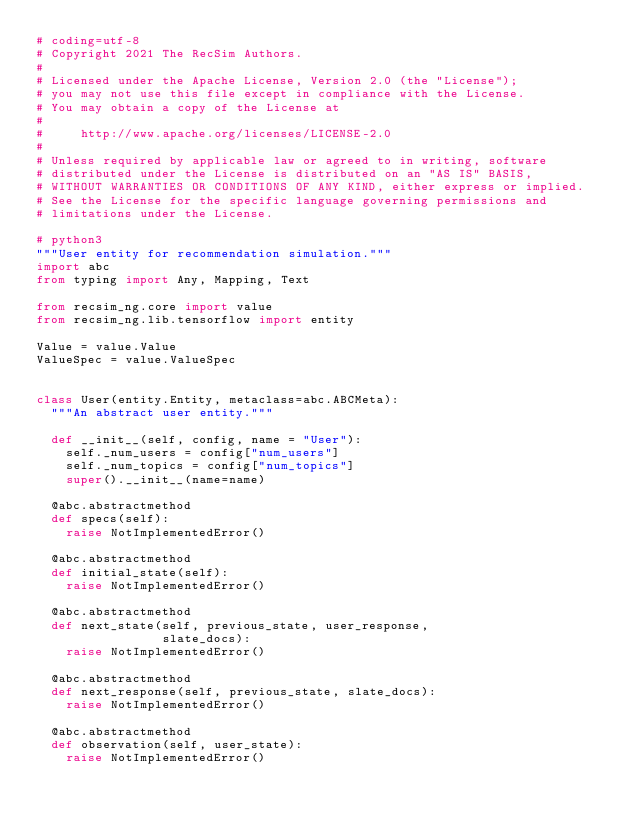Convert code to text. <code><loc_0><loc_0><loc_500><loc_500><_Python_># coding=utf-8
# Copyright 2021 The RecSim Authors.
#
# Licensed under the Apache License, Version 2.0 (the "License");
# you may not use this file except in compliance with the License.
# You may obtain a copy of the License at
#
#     http://www.apache.org/licenses/LICENSE-2.0
#
# Unless required by applicable law or agreed to in writing, software
# distributed under the License is distributed on an "AS IS" BASIS,
# WITHOUT WARRANTIES OR CONDITIONS OF ANY KIND, either express or implied.
# See the License for the specific language governing permissions and
# limitations under the License.

# python3
"""User entity for recommendation simulation."""
import abc
from typing import Any, Mapping, Text

from recsim_ng.core import value
from recsim_ng.lib.tensorflow import entity

Value = value.Value
ValueSpec = value.ValueSpec


class User(entity.Entity, metaclass=abc.ABCMeta):
  """An abstract user entity."""

  def __init__(self, config, name = "User"):
    self._num_users = config["num_users"]
    self._num_topics = config["num_topics"]
    super().__init__(name=name)

  @abc.abstractmethod
  def specs(self):
    raise NotImplementedError()

  @abc.abstractmethod
  def initial_state(self):
    raise NotImplementedError()

  @abc.abstractmethod
  def next_state(self, previous_state, user_response,
                 slate_docs):
    raise NotImplementedError()

  @abc.abstractmethod
  def next_response(self, previous_state, slate_docs):
    raise NotImplementedError()

  @abc.abstractmethod
  def observation(self, user_state):
    raise NotImplementedError()
</code> 